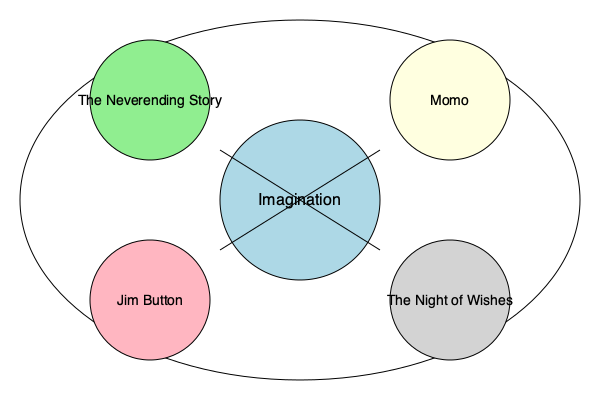Based on the interconnected web diagram of Michael Ende's major works, which central theme connects all of his stories, and how does it manifest differently in each book? 1. Central Theme: The diagram shows "Imagination" at the center, connecting all of Ende's major works. This suggests that imagination is the core theme that runs through his stories.

2. The Neverending Story:
   - Imagination manifests as a magical book that allows the protagonist to enter a fantasy world.
   - The power of imagination is crucial in saving Fantasia from destruction.

3. Momo:
   - Imagination is represented through the concept of time and its perception.
   - The protagonist uses her imaginative abilities to combat the time thieves and restore balance.

4. Jim Button:
   - Imagination is evident in the fantastical world of Morrowland and its inhabitants.
   - The protagonist's journey is filled with imaginative encounters and problem-solving.

5. The Night of Wishes:
   - Imagination appears in the form of magical creatures and spells.
   - The story explores the imaginative potential of wishes and their consequences.

6. Interconnectedness:
   - All four works are connected to the central theme of imagination, showing how Ende consistently used this concept as a driving force in his storytelling.
   - Each book explores imagination in a unique way, demonstrating Ende's versatility in applying this theme to different narratives and settings.
Answer: Imagination, manifesting as fantasy worlds, time perception, magical journeys, and wishes in Ende's different works. 